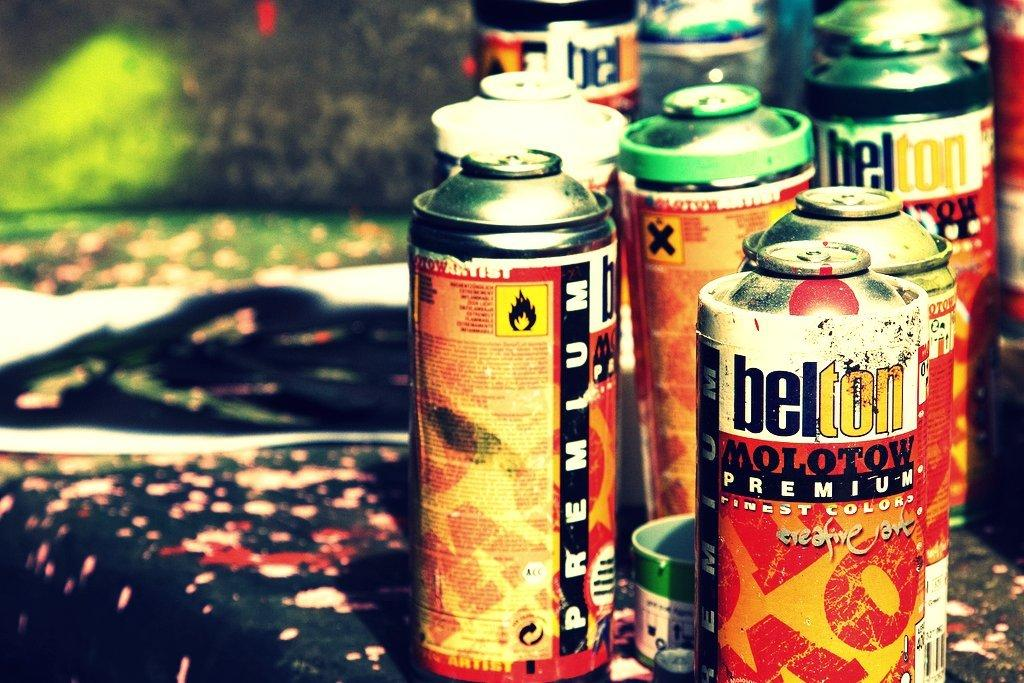<image>
Describe the image concisely. A row of paint cans that say belton Molotow are on a messy table. 